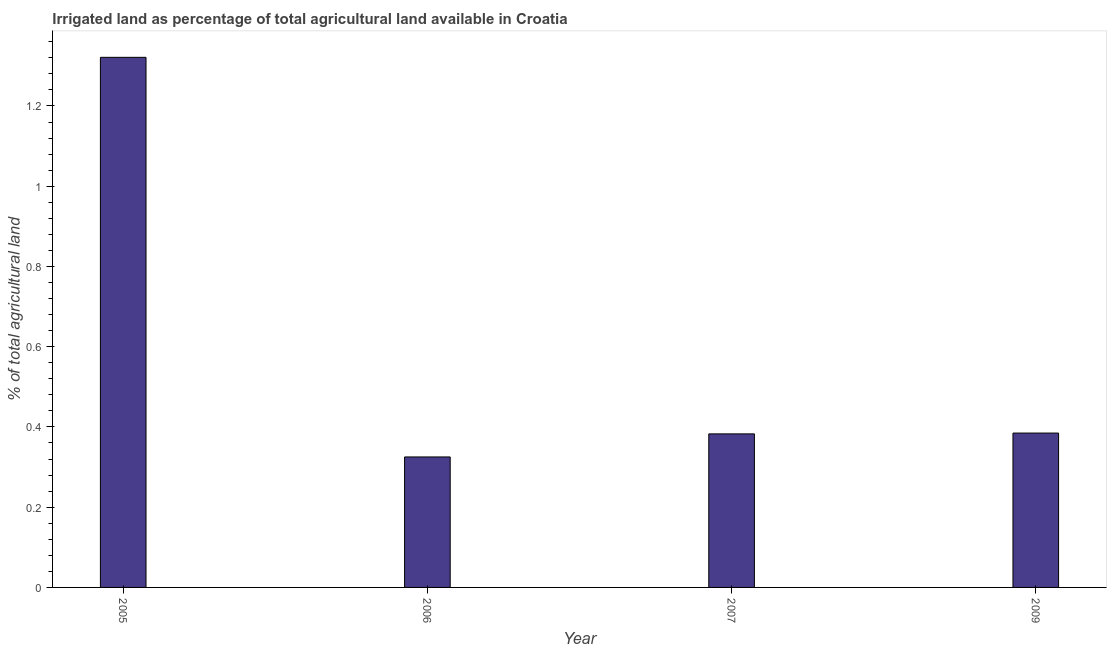Does the graph contain any zero values?
Keep it short and to the point. No. What is the title of the graph?
Your answer should be very brief. Irrigated land as percentage of total agricultural land available in Croatia. What is the label or title of the Y-axis?
Ensure brevity in your answer.  % of total agricultural land. What is the percentage of agricultural irrigated land in 2006?
Your response must be concise. 0.33. Across all years, what is the maximum percentage of agricultural irrigated land?
Provide a succinct answer. 1.32. Across all years, what is the minimum percentage of agricultural irrigated land?
Provide a succinct answer. 0.33. In which year was the percentage of agricultural irrigated land maximum?
Give a very brief answer. 2005. In which year was the percentage of agricultural irrigated land minimum?
Your answer should be very brief. 2006. What is the sum of the percentage of agricultural irrigated land?
Give a very brief answer. 2.41. What is the difference between the percentage of agricultural irrigated land in 2006 and 2007?
Offer a very short reply. -0.06. What is the average percentage of agricultural irrigated land per year?
Offer a very short reply. 0.6. What is the median percentage of agricultural irrigated land?
Your response must be concise. 0.38. What is the ratio of the percentage of agricultural irrigated land in 2006 to that in 2007?
Offer a terse response. 0.85. Is the percentage of agricultural irrigated land in 2006 less than that in 2007?
Offer a terse response. Yes. Is the difference between the percentage of agricultural irrigated land in 2005 and 2007 greater than the difference between any two years?
Your answer should be compact. No. What is the difference between the highest and the second highest percentage of agricultural irrigated land?
Provide a short and direct response. 0.94. Is the sum of the percentage of agricultural irrigated land in 2005 and 2009 greater than the maximum percentage of agricultural irrigated land across all years?
Offer a terse response. Yes. What is the difference between the highest and the lowest percentage of agricultural irrigated land?
Ensure brevity in your answer.  1. How many years are there in the graph?
Ensure brevity in your answer.  4. What is the difference between two consecutive major ticks on the Y-axis?
Give a very brief answer. 0.2. What is the % of total agricultural land of 2005?
Offer a very short reply. 1.32. What is the % of total agricultural land of 2006?
Your response must be concise. 0.33. What is the % of total agricultural land in 2007?
Offer a very short reply. 0.38. What is the % of total agricultural land of 2009?
Your answer should be compact. 0.38. What is the difference between the % of total agricultural land in 2005 and 2006?
Keep it short and to the point. 1. What is the difference between the % of total agricultural land in 2005 and 2007?
Your response must be concise. 0.94. What is the difference between the % of total agricultural land in 2005 and 2009?
Your answer should be very brief. 0.94. What is the difference between the % of total agricultural land in 2006 and 2007?
Offer a very short reply. -0.06. What is the difference between the % of total agricultural land in 2006 and 2009?
Offer a terse response. -0.06. What is the difference between the % of total agricultural land in 2007 and 2009?
Your answer should be compact. -0. What is the ratio of the % of total agricultural land in 2005 to that in 2006?
Keep it short and to the point. 4.06. What is the ratio of the % of total agricultural land in 2005 to that in 2007?
Make the answer very short. 3.45. What is the ratio of the % of total agricultural land in 2005 to that in 2009?
Keep it short and to the point. 3.43. What is the ratio of the % of total agricultural land in 2006 to that in 2009?
Your response must be concise. 0.84. What is the ratio of the % of total agricultural land in 2007 to that in 2009?
Give a very brief answer. 0.99. 